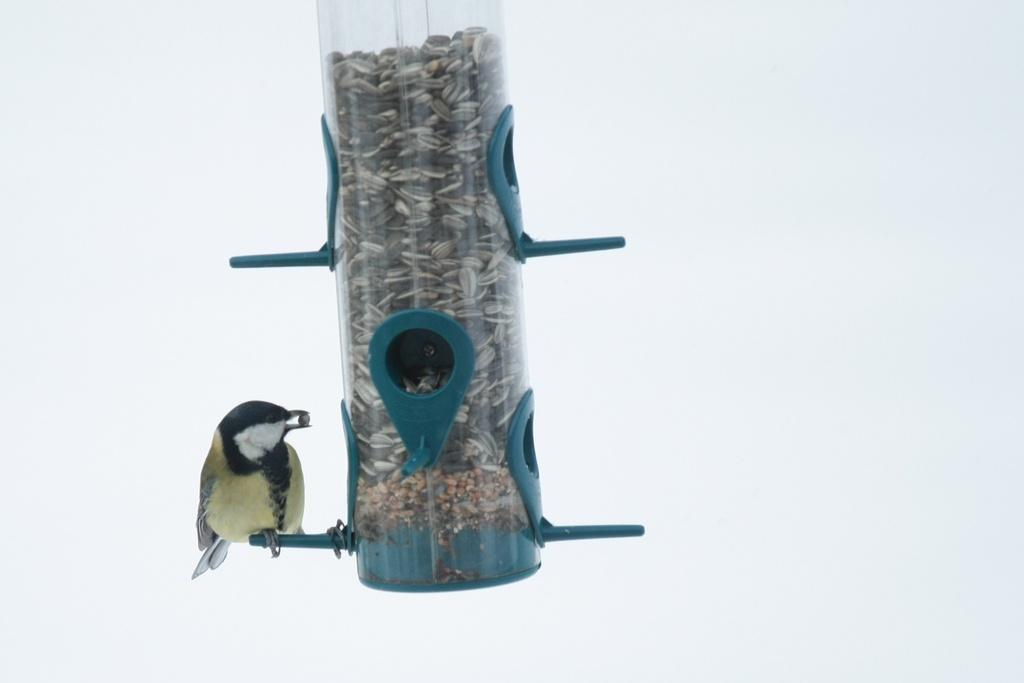What type of animal is in the image? There is a bird in the image. What is the bird standing on? The bird is standing on an upside-down thistle tube feeder. How much honey is the bird collecting from the thistle tube feeder in the image? There is no honey present in the image, as the bird is standing on an upside-down thistle tube feeder, not a honey source. 